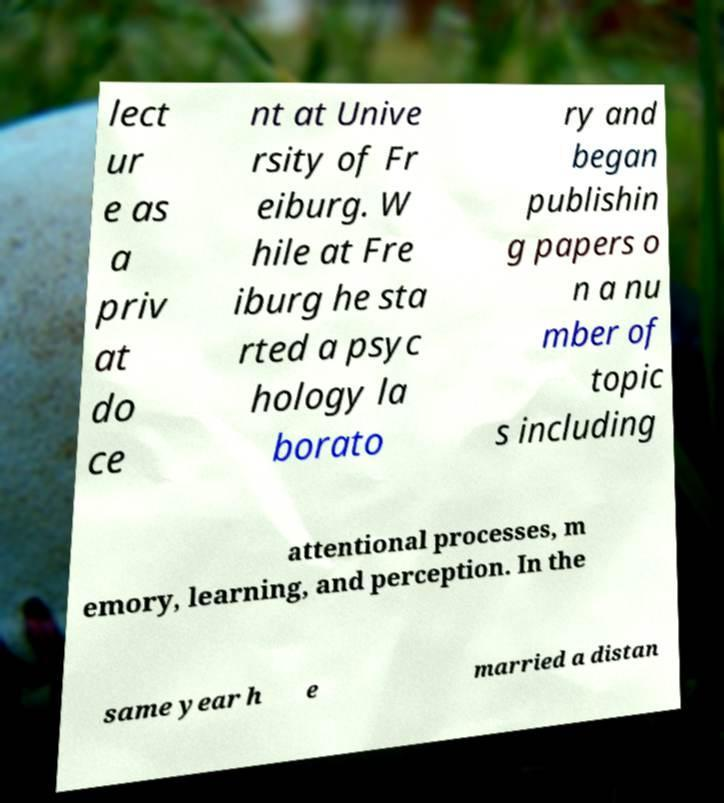Please identify and transcribe the text found in this image. lect ur e as a priv at do ce nt at Unive rsity of Fr eiburg. W hile at Fre iburg he sta rted a psyc hology la borato ry and began publishin g papers o n a nu mber of topic s including attentional processes, m emory, learning, and perception. In the same year h e married a distan 